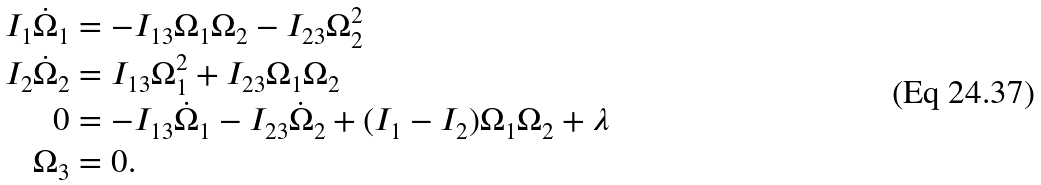Convert formula to latex. <formula><loc_0><loc_0><loc_500><loc_500>I _ { 1 } \dot { \Omega } _ { 1 } & = - I _ { 1 3 } \Omega _ { 1 } \Omega _ { 2 } - I _ { 2 3 } \Omega _ { 2 } ^ { 2 } \\ I _ { 2 } \dot { \Omega } _ { 2 } & = I _ { 1 3 } \Omega _ { 1 } ^ { 2 } + I _ { 2 3 } \Omega _ { 1 } \Omega _ { 2 } \\ 0 & = - I _ { 1 3 } \dot { \Omega } _ { 1 } - I _ { 2 3 } \dot { \Omega } _ { 2 } + ( I _ { 1 } - I _ { 2 } ) \Omega _ { 1 } \Omega _ { 2 } + \lambda \\ \Omega _ { 3 } & = 0 .</formula> 